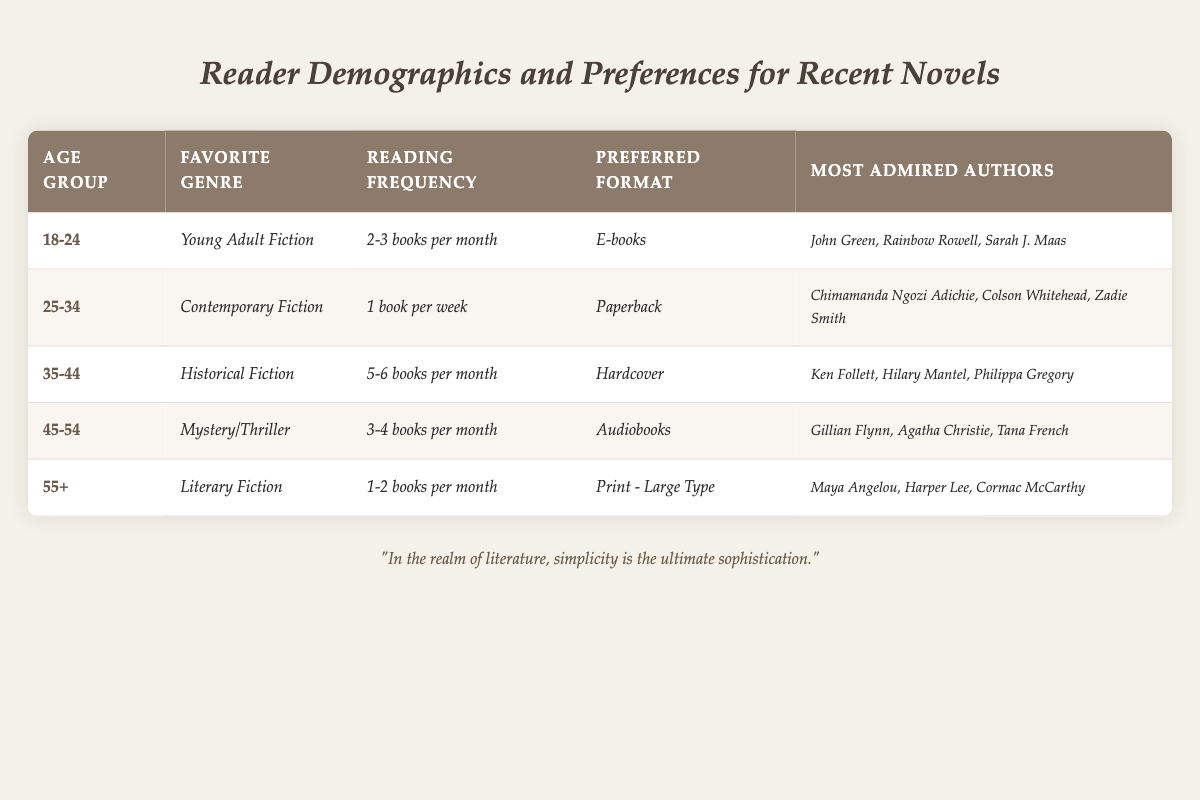What is the favorite genre of readers aged 18-24? According to the table, the favorite genre for the age group 18-24 is displayed in the corresponding row under "Favorite Genre," which reads "*Young Adult Fiction*."
Answer: Young Adult Fiction How often do readers in the 45-54 age group read books? The reading frequency for the 45-54 age group can be found in their row under the "Reading Frequency" column, which states "*3-4 books per month*."
Answer: 3-4 books per month Which reading format is preferred by readers aged 35-44? Under the "Preferred Format" column in the row for the 35-44 age group, the data indicates "*Hardcover*."
Answer: Hardcover True or False: The majority of readers aged 55 and older prefer print books in large type. The data in the 55+ age group row indicates that their preferred format is "*Print - Large Type*," confirming the statement as true.
Answer: True What is the difference in reading frequency between the 25-34 and 45-54 age groups? The reading frequency for the 25-34 age group is "*1 book per week*" (which is approximately 4 books per month), while for the 45-54 age group it is "*3-4 books per month*." The difference is calculated as 4 - 3.5 (average of 3-4) = 0.5 books per month.
Answer: 0.5 books per month Which authors are most admired by the 35-44 age group? The row for the 35-44 age group lists the most admired authors under the "Most Admired Authors" column, which names "*Ken Follett, Hilary Mantel, Philippa Gregory*."
Answer: Ken Follett, Hilary Mantel, Philippa Gregory How many books does the 55+ age group read in comparison to the 18-24 age group? The 55+ age group reads "*1-2 books per month*," while the 18-24 age group reads "*2-3 books per month*." The average monthly reading for the 55+ age group is 1.5 books, while for the 18-24 age group, it is 2.5 books. Thus, the difference is 2.5 - 1.5 = 1 book per month.
Answer: 1 book per month Which age group reads the most, and what is their reading frequency? The age group that reads the most is the 35-44 group, which reads "*5-6 books per month.*" This is clearly indicated in their row under the "Reading Frequency" column.
Answer: 5-6 books per month Are there any similarities in preferred formats between the 25-34 and 45-54 age groups? The 25-34 age group prefers "*Paperback*," while the 45-54 age group prefers "*Audiobooks*." Since neither format is the same, there are no similarities in preferred formats.
Answer: No What is the most admired author for the age group that prefers Mystery/Thriller? The most admired authors for the 45-54 age group, who prefer "*Mystery/Thriller*," are "*Gillian Flynn, Agatha Christie, Tana French*," as noted in their corresponding row.
Answer: Gillian Flynn, Agatha Christie, Tana French 